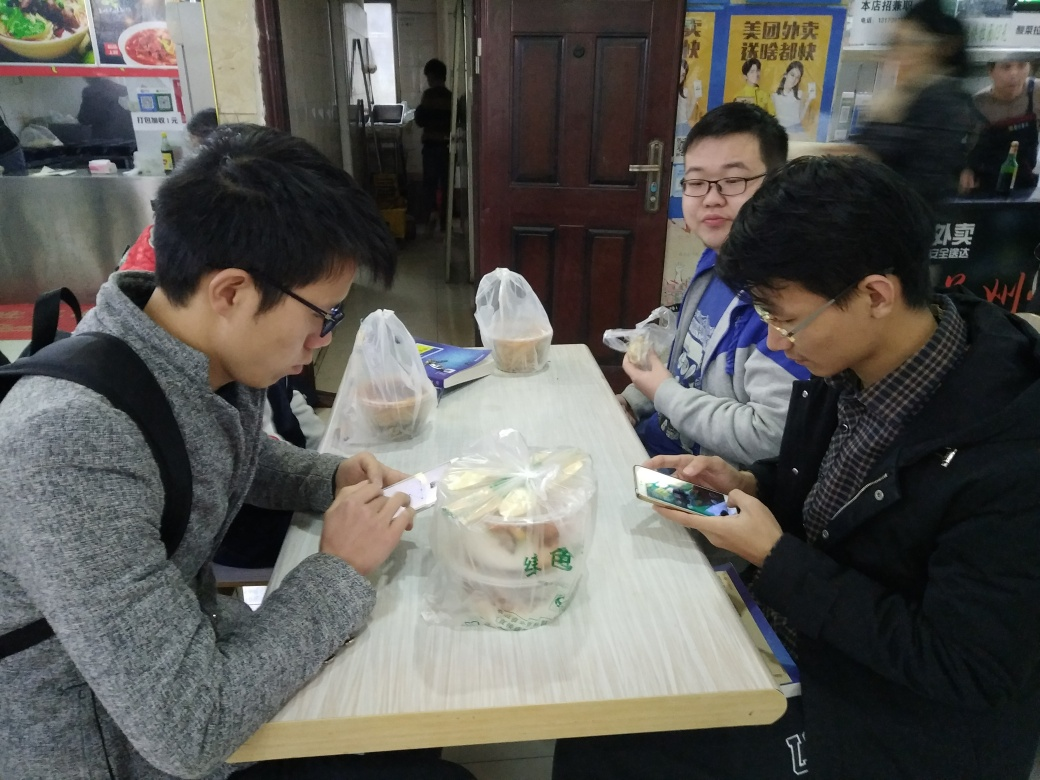What time of day does it appear to be in the photograph? The lighting in the photograph does not provide clear indicators of the time of day, as the source of light appears to be artificial, coming from within the establishment. However, the casual attire of the individuals, along with the nature of the meals—fast-food containers and snacks—could suggest that it might be lunchtime or afternoon, a common time for people to enjoy a quick meal or a snack break during their daily routines. 